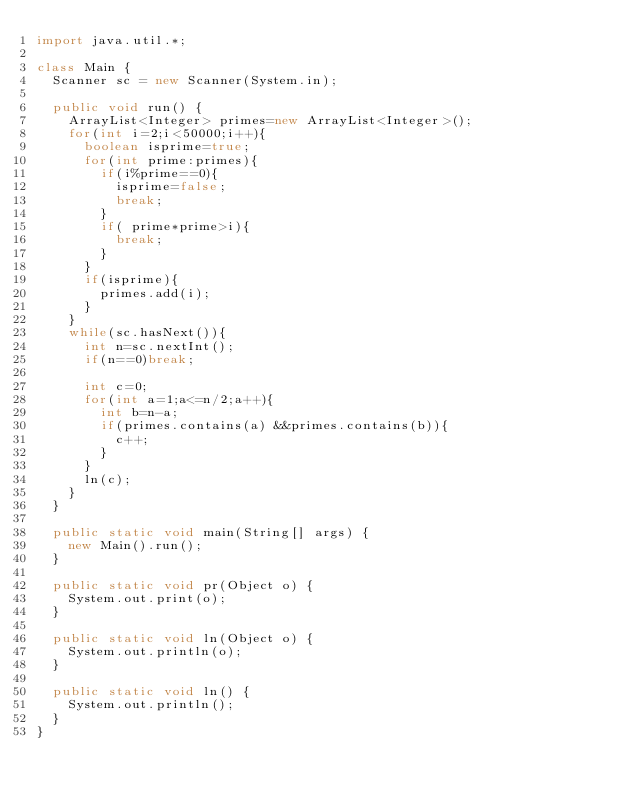<code> <loc_0><loc_0><loc_500><loc_500><_Java_>import java.util.*;

class Main {
	Scanner sc = new Scanner(System.in);

	public void run() {
		ArrayList<Integer> primes=new ArrayList<Integer>();
		for(int i=2;i<50000;i++){
			boolean isprime=true;
			for(int prime:primes){
				if(i%prime==0){
					isprime=false;
					break;
				}
				if( prime*prime>i){
					break;
				}
			}
			if(isprime){
				primes.add(i);
			}
		}
		while(sc.hasNext()){
			int n=sc.nextInt();
			if(n==0)break;

			int c=0;
			for(int a=1;a<=n/2;a++){
				int b=n-a;
				if(primes.contains(a) &&primes.contains(b)){
					c++;
				}
			}
			ln(c);
		}
	}

	public static void main(String[] args) {
		new Main().run();
	}

	public static void pr(Object o) {
		System.out.print(o);
	}

	public static void ln(Object o) {
		System.out.println(o);
	}

	public static void ln() {
		System.out.println();
	}
}</code> 